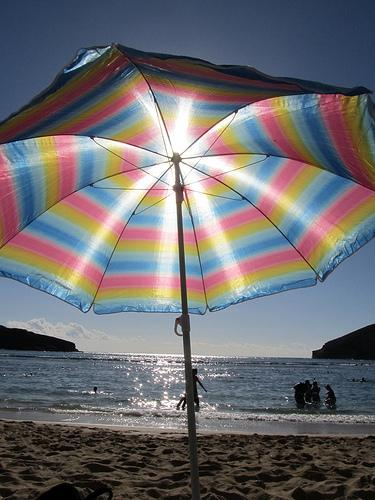Describe the umbrella in details of its color and structure. The umbrella has eight segments, with yellow, blue, pink, and white stripes on it, and an adjustable pole in the sand. Provide a sentiment analysis of the image, describing the emotions and atmosphere it portrays. The image portrays a lively and fun atmosphere with people enjoying their time at the beach, swimming and playing together under a clear blue sky, with a sense of relaxation and happiness in the scene. Provide a general description of the image. There are people at the beach with a tall striped beach umbrella in the sand, a body of water with people playing in it, a dark blue sky with a few clouds, and rocky outcroppings in the distance. Identify the number of people in the water and describe their appearance. There are four people in the water, with one person's head poking out, a man behind an umbrella pole, and another group of people consisting of a man playing with his son and a lone boy bobbing in the water. Mention the color of the sky and state the presence of any cloud in the image. The sky is dark blue, and there is a lonely puffy cloud in the sky. Count the total number of people and describe their activities in the image. There are seven people in total in the image with four playing in the water, a man walking his dog in the surf, and two others swimming. Describe the condition of the sand and the water in the image. The sand is trampled grey with many footprints, and the water is slightly choppy and shiny blue. Describe the type and colors of the umbrella on the sand. It's a tall beach umbrella with eight rainbow striped panels, and visible colors are yellow, blue, pink, red, and white. Describe the appearance and condition of the water. The water is a shiny blue color, with sun glinting off it, and it appears to be slightly choppy with some people swimming in it. Examine the interaction between people and the environment in the image. The people are enjoying their time at the beach swimming and playing in the water while interacting with the dog and each other, and a man is walking his dog in the surf. Can you spot the dolphin jumping out of the water near the group of people? There is a dolphin gracefully leaping out of the water next to those four people. What type of water is present in the image? The image shows a body of slightly choppy, shiny blue water in a bay. Where did that little girl place her sandcastle on this busy beach? The little girl carefully built her sandcastle near the footprints in the sand. Who is the woman holding a surfboard on the right side of the image? The woman with the surfboard is preparing to catch some waves. Can you find the smiling grandparents sitting in their beach chairs under the umbrella? The happy grandparents enjoy their time under the umbrella, watching their family in the water. What objects are in the background? In the background, there is a black rocky cliff and a line of rocks off the shore. List the colors of the umbrella. Yellow, blue, pink, and white. Identify the object at coordinates X:167, Y:285 with Width:42 and Height:42. An umbrella pole in the sand. Where did the couple set their picnic blanket in the trampled sand area? The couple placed their picnic blanket next to the umbrella, ready for a romantic lunch. What is the position of the sun? The sun is not visible in the image, but it is shining through the umbrella and reflecting on the water. Assess the quality of the image. The image quality is good with clear and sharp objects. What is the dominant color of the umbrella? The umbrella is multicolored with yellow, blue, pink, and white. How many people are in the water? There are four people in the water. What activity are the people participating in? The people are swimming and playing in the water. Are there any animals in the image? No animals are present in the image. How would you describe the sand in the image? The sand is trampled with many footprints and it appears brown and gray. What is the sentiment conveyed by the image? The image conveys a joyful and relaxed sentiment of people enjoying a day at the beach. Describe the condition of the sky. The sky is clear and dark blue with a few clouds. Does the image have any negative connotations? No, the image has a positive beach scene vibe. Is there an umbrella in the image? Yes, there is a tall, striped beach umbrella in the sand. Can you detect an anomaly in the image? No anomaly detected. Does the scenery change from left to right in any significant way? The scenery changes from a black rocky cliff on the left to a clearer view of the beach and water on the right. Describe the content of the image. The image shows a beach scene with four people in the water, a striped beach umbrella, many footprints in the sand, and a black rocky cliff in the background. Have you noticed the seagulls flying low over the shiny blue water? Several seagulls are swooping down over the water, looking for fish. What objects or people are interacting with the water? Four people are playing in the water, including a man walking his dog in the surf and a lone boy bobbing in the water. Are there any clouds in the sky in the image? Yes, there is one lonely puffy cloud in the sky. 